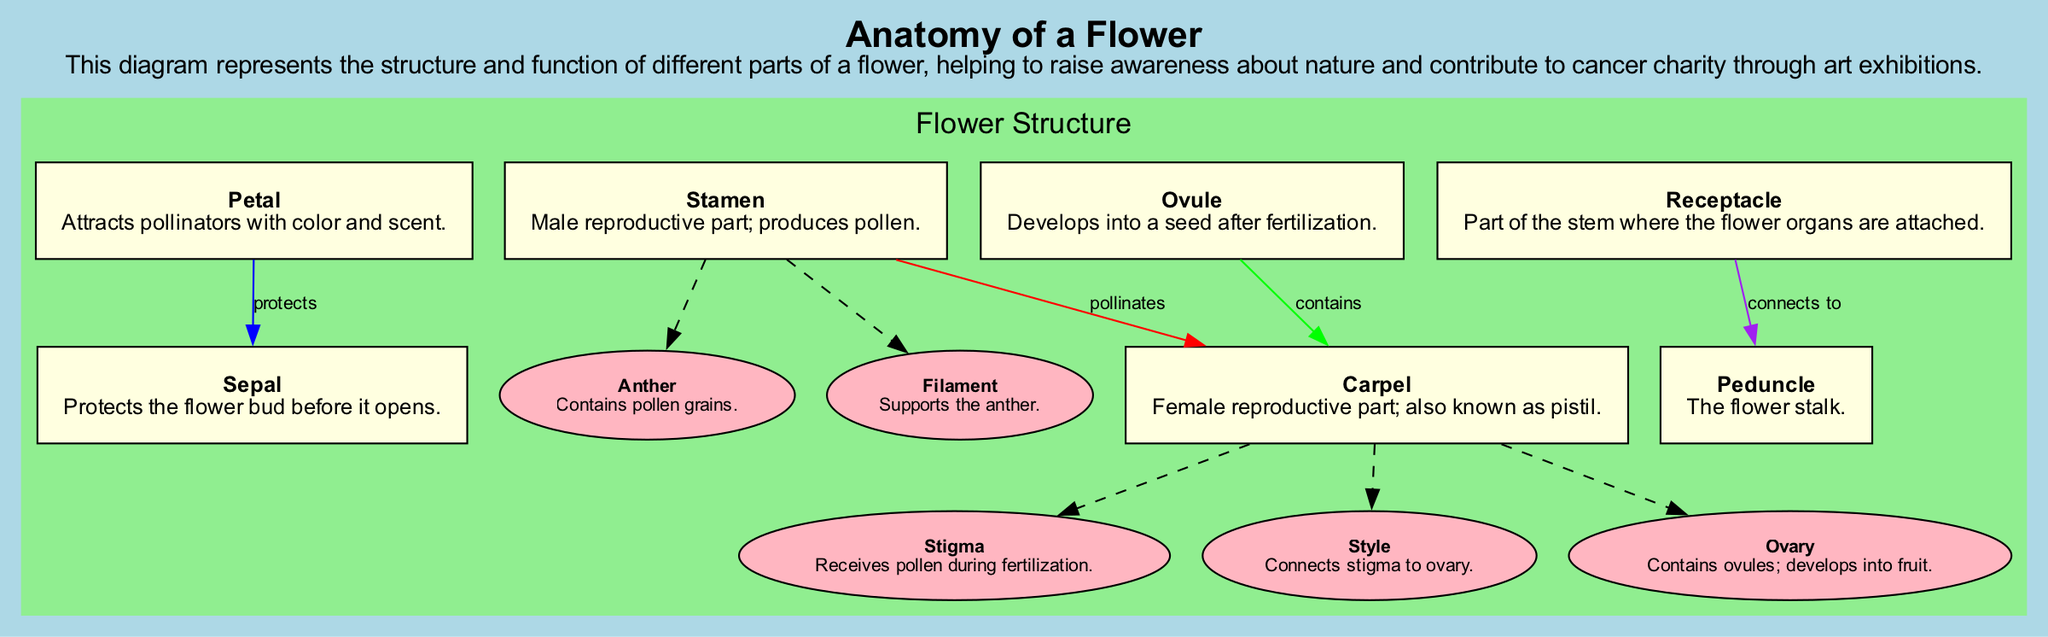What is the primary role of the petal? The petal is described as attracting pollinators with color and scent. This function highlights its importance in the reproductive process of the flower.
Answer: Attracts pollinators How many subsections are present in the carpel? The carpel has three subsections: stigma, style, and ovary. Counting these gives a total of three.
Answer: Three What connects the stigma to the ovary? The diagram indicates that the style connects the stigma to the ovary. This connection is important for the fertilization process.
Answer: Style Which part contains pollen grains? The anther, a subsection of the stamen, is specifically noted for containing pollen grains. This identifies the male reproductive component of the flower.
Answer: Anther What is the relationship between the stamen and the carpel? The diagram shows that the stamen pollinates the carpel, indicating the interaction necessary for reproduction. This highlights a key functional relationship in the flower.
Answer: Pollinates How many main sections are there in the flower structure? The main flower structure contains six sections: petal, sepal, stamen, carpel, ovule, and receptacle. Counting these gives a total of six.
Answer: Six Which part of the flower develops into fruit? The ovary is identified in the diagram as the part that develops into fruit, after containing the ovules. This illustrates its crucial role in the reproductive cycle.
Answer: Ovary What does the sepal do? The sepal is described as protecting the flower bud before it opens, showcasing its role in safeguarding the developing flower.
Answer: Protects the flower bud What is the overall function of the receptacle? The receptacle is described as being the part of the stem where the flower organs are attached. This indicates its supportive function in the structure of the flower.
Answer: Supports flower organs 